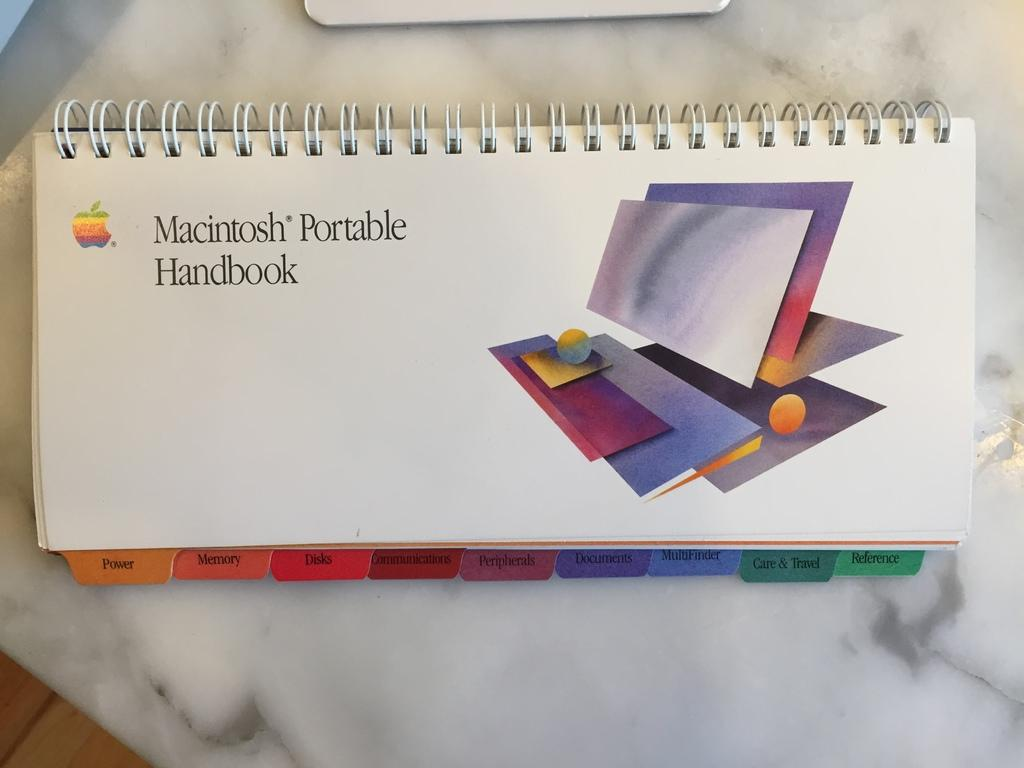<image>
Share a concise interpretation of the image provided. a Macintosh Portable handbook with various colored tabs 